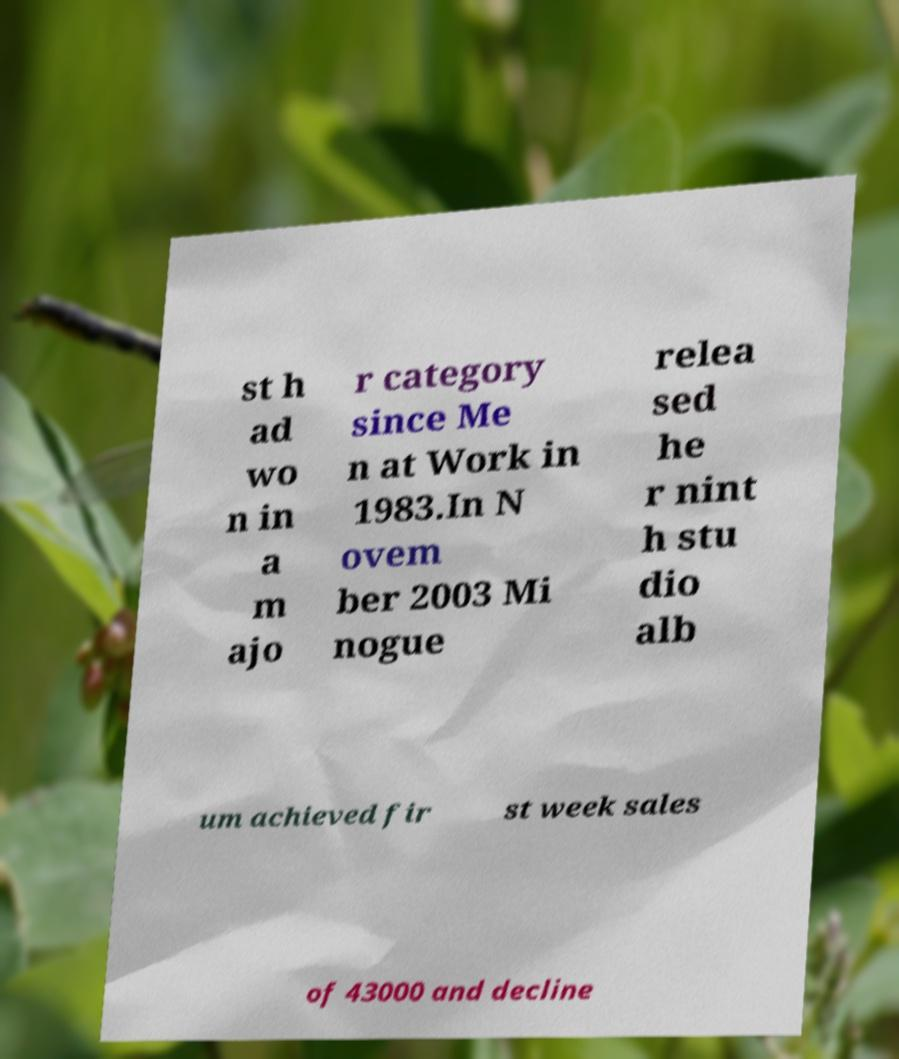I need the written content from this picture converted into text. Can you do that? st h ad wo n in a m ajo r category since Me n at Work in 1983.In N ovem ber 2003 Mi nogue relea sed he r nint h stu dio alb um achieved fir st week sales of 43000 and decline 